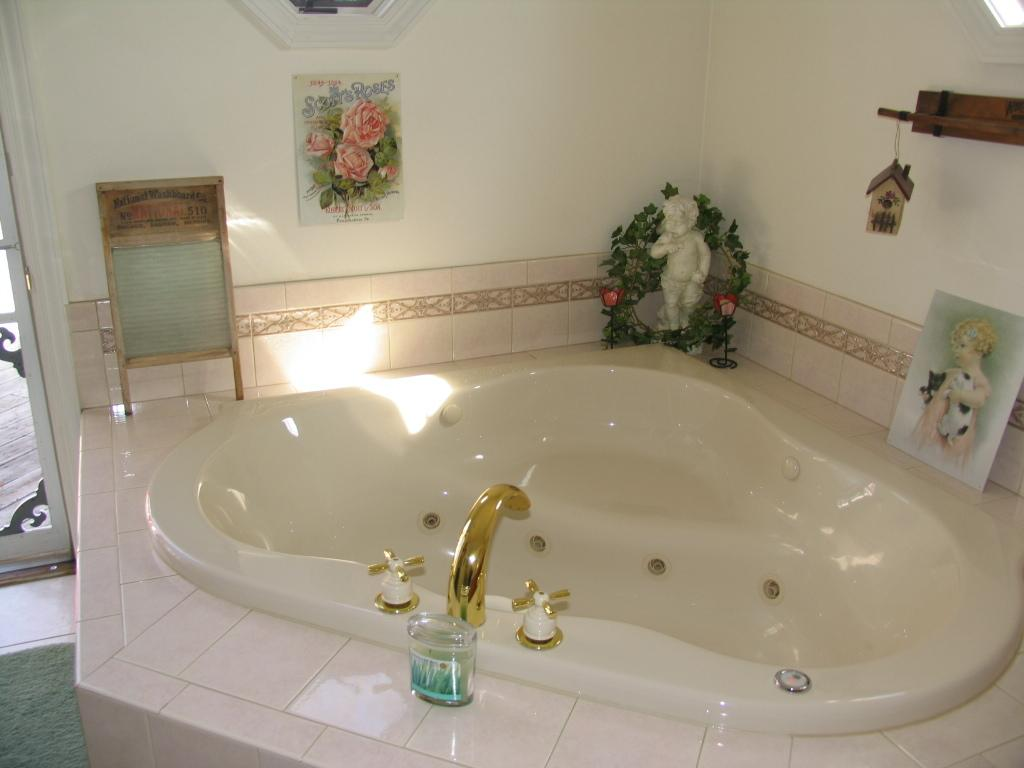What is the main object in the foreground of the image? There is a bath tub in the foreground of the image. What is located near the bath tub? There is a tap, posters, a sculpture, a wooden toy house, a wall, and a door in the foreground of the image. Can you describe the posters in the image? The posters are located near the bath tub, but their content or design cannot be determined from the provided facts. What type of material is the door made of? The material of the door cannot be determined from the provided facts. How does the horse contribute to the power supply in the image? There is no horse present in the image, so it cannot contribute to the power supply. 